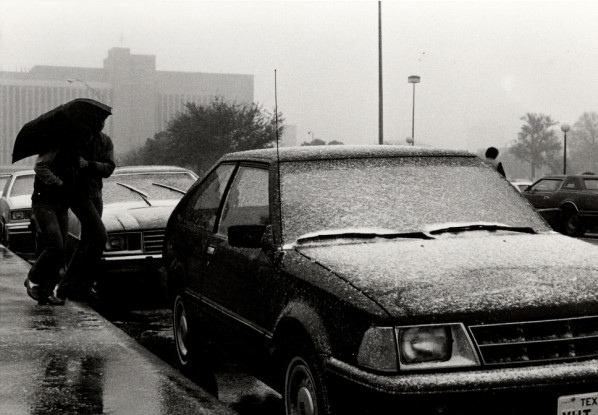Identify the text contained in this image. TEX 